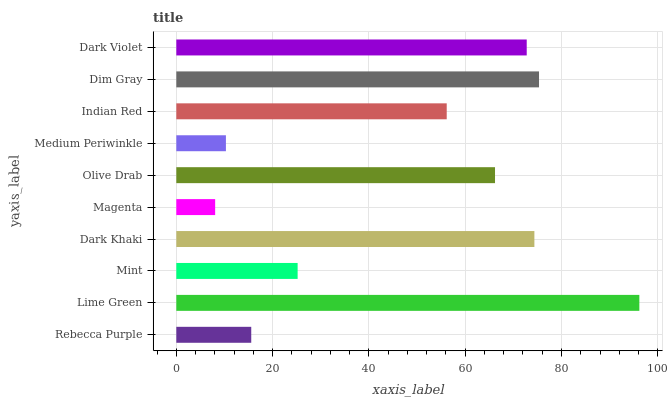Is Magenta the minimum?
Answer yes or no. Yes. Is Lime Green the maximum?
Answer yes or no. Yes. Is Mint the minimum?
Answer yes or no. No. Is Mint the maximum?
Answer yes or no. No. Is Lime Green greater than Mint?
Answer yes or no. Yes. Is Mint less than Lime Green?
Answer yes or no. Yes. Is Mint greater than Lime Green?
Answer yes or no. No. Is Lime Green less than Mint?
Answer yes or no. No. Is Olive Drab the high median?
Answer yes or no. Yes. Is Indian Red the low median?
Answer yes or no. Yes. Is Dark Khaki the high median?
Answer yes or no. No. Is Olive Drab the low median?
Answer yes or no. No. 